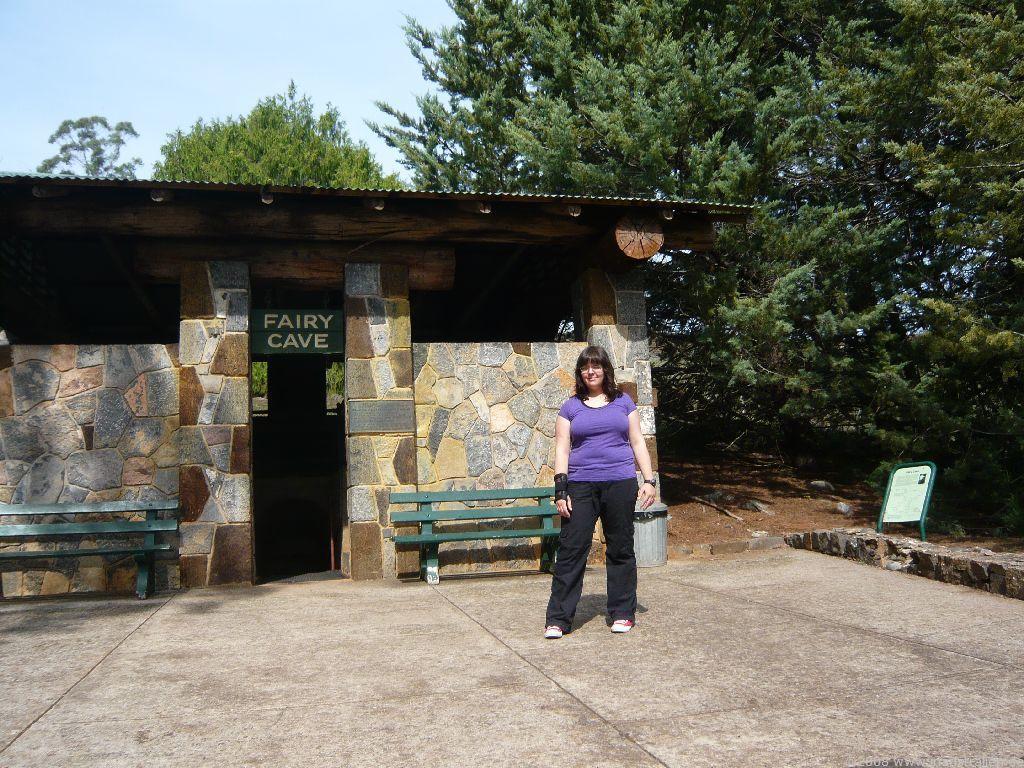Can you describe this image briefly? In this picture we can see woman standing on floor and in background we can see shelter, benches, name board, trees, sky. 